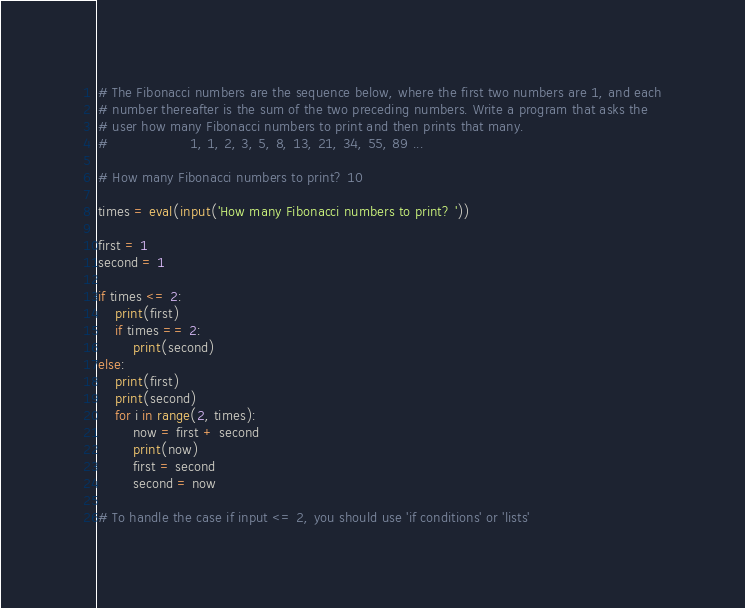<code> <loc_0><loc_0><loc_500><loc_500><_Python_># The Fibonacci numbers are the sequence below, where the first two numbers are 1, and each
# number thereafter is the sum of the two preceding numbers. Write a program that asks the
# user how many Fibonacci numbers to print and then prints that many.
#                   1, 1, 2, 3, 5, 8, 13, 21, 34, 55, 89 ...

# How many Fibonacci numbers to print? 10

times = eval(input('How many Fibonacci numbers to print? '))

first = 1
second = 1

if times <= 2:
    print(first)
    if times == 2:
        print(second)
else:
    print(first)
    print(second)
    for i in range(2, times):
        now = first + second
        print(now)
        first = second
        second = now

# To handle the case if input <= 2, you should use 'if conditions' or 'lists'
</code> 